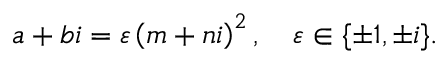Convert formula to latex. <formula><loc_0><loc_0><loc_500><loc_500>a + b i = \varepsilon \left ( m + n i \right ) ^ { 2 } , \quad \varepsilon \in \{ \pm 1 , \pm i \} .</formula> 